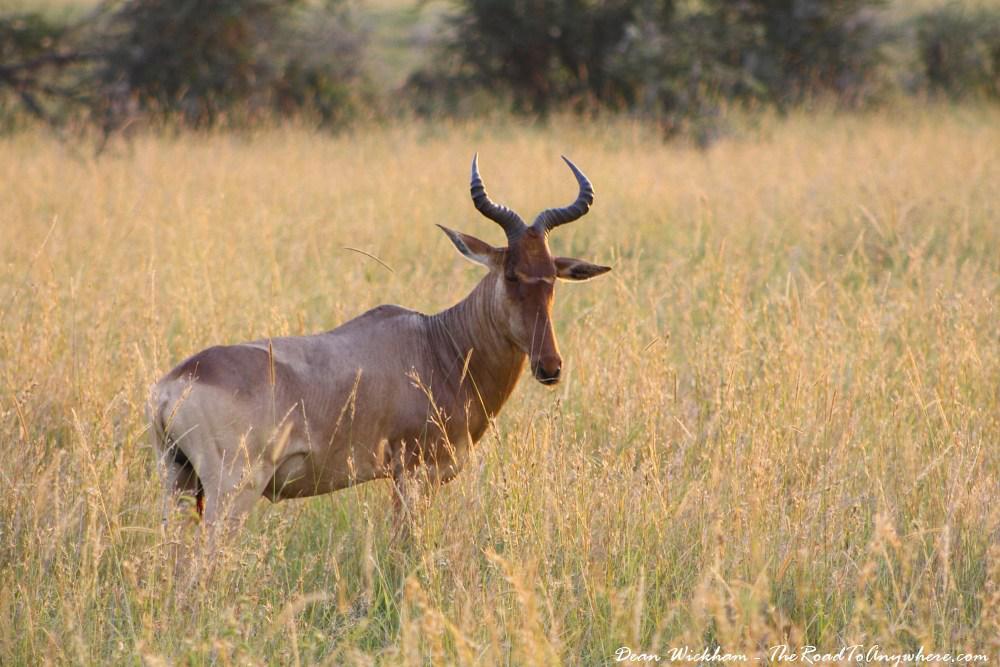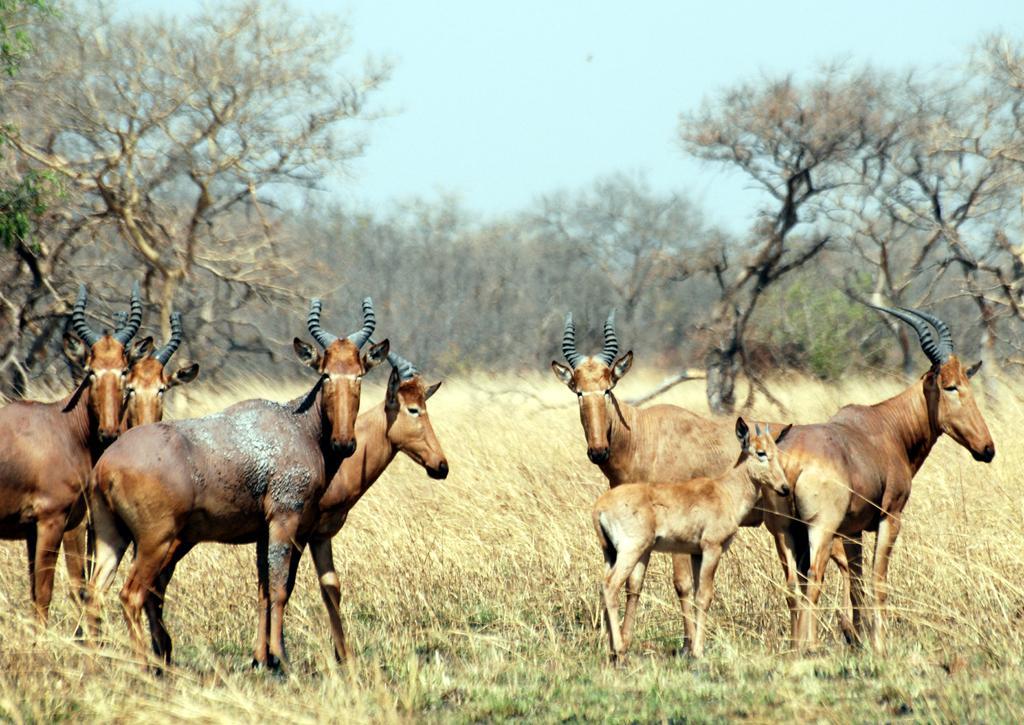The first image is the image on the left, the second image is the image on the right. Assess this claim about the two images: "A single horned animal is standing in the grass in the image on the left.". Correct or not? Answer yes or no. Yes. The first image is the image on the left, the second image is the image on the right. For the images displayed, is the sentence "Left image contains one horned animal, standing with its body turned rightward." factually correct? Answer yes or no. Yes. 